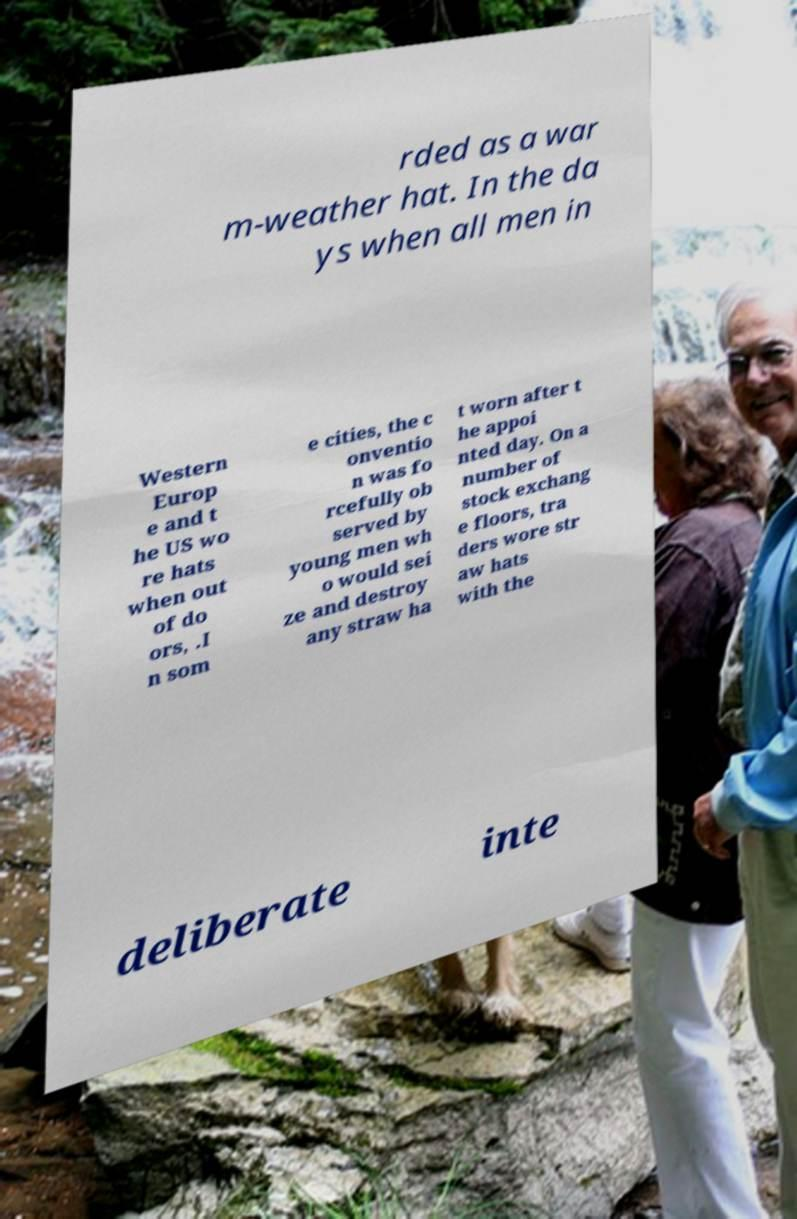I need the written content from this picture converted into text. Can you do that? rded as a war m-weather hat. In the da ys when all men in Western Europ e and t he US wo re hats when out of do ors, .I n som e cities, the c onventio n was fo rcefully ob served by young men wh o would sei ze and destroy any straw ha t worn after t he appoi nted day. On a number of stock exchang e floors, tra ders wore str aw hats with the deliberate inte 